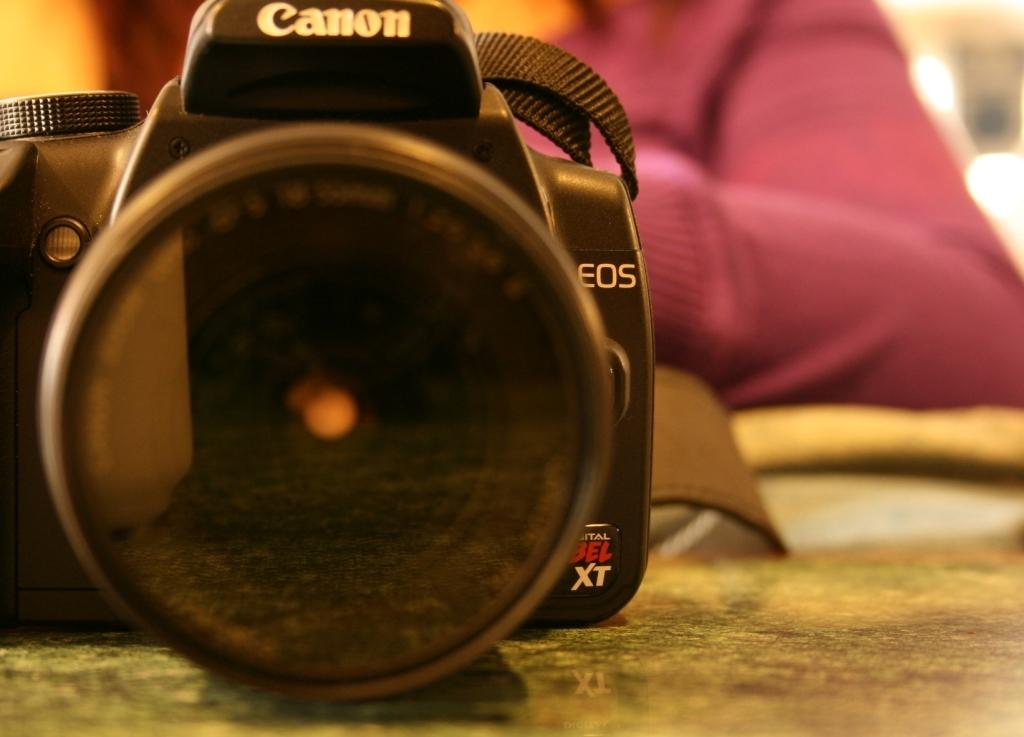What object is placed on a surface in the image? There is a camera placed on a surface in the image. What can be observed about the background of the image? The background of the image is blurred. Can you describe the person in the image? The person in the image is wearing a maroon-colored dress. What type of dog can be seen playing with the camera in the image? There is no dog present in the image; it features a camera placed on a surface and a person wearing a maroon-colored dress. 